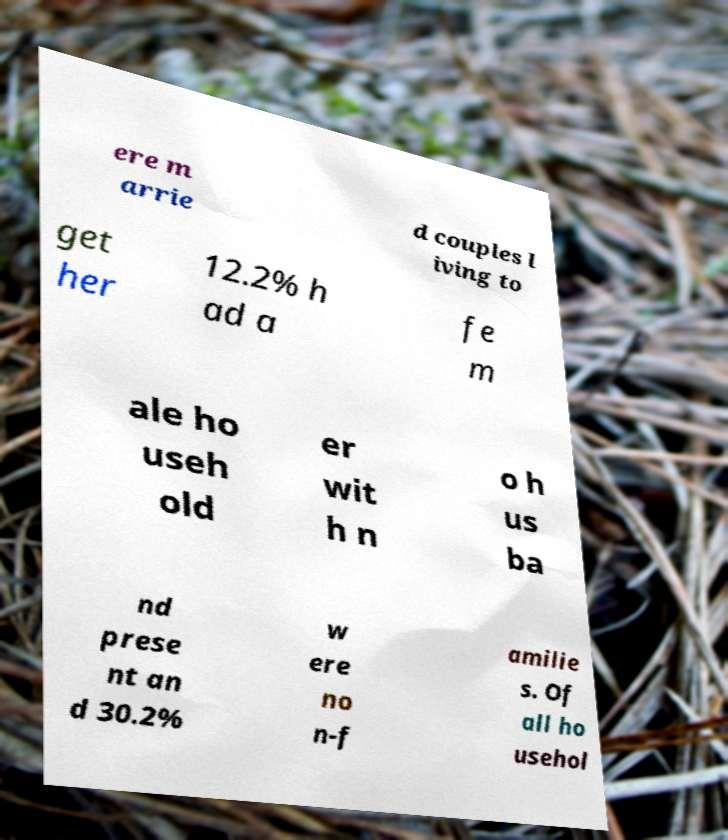What messages or text are displayed in this image? I need them in a readable, typed format. ere m arrie d couples l iving to get her 12.2% h ad a fe m ale ho useh old er wit h n o h us ba nd prese nt an d 30.2% w ere no n-f amilie s. Of all ho usehol 